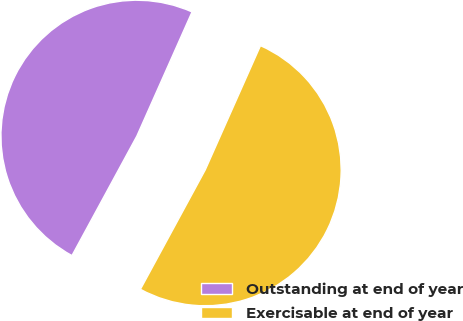Convert chart to OTSL. <chart><loc_0><loc_0><loc_500><loc_500><pie_chart><fcel>Outstanding at end of year<fcel>Exercisable at end of year<nl><fcel>48.74%<fcel>51.26%<nl></chart> 